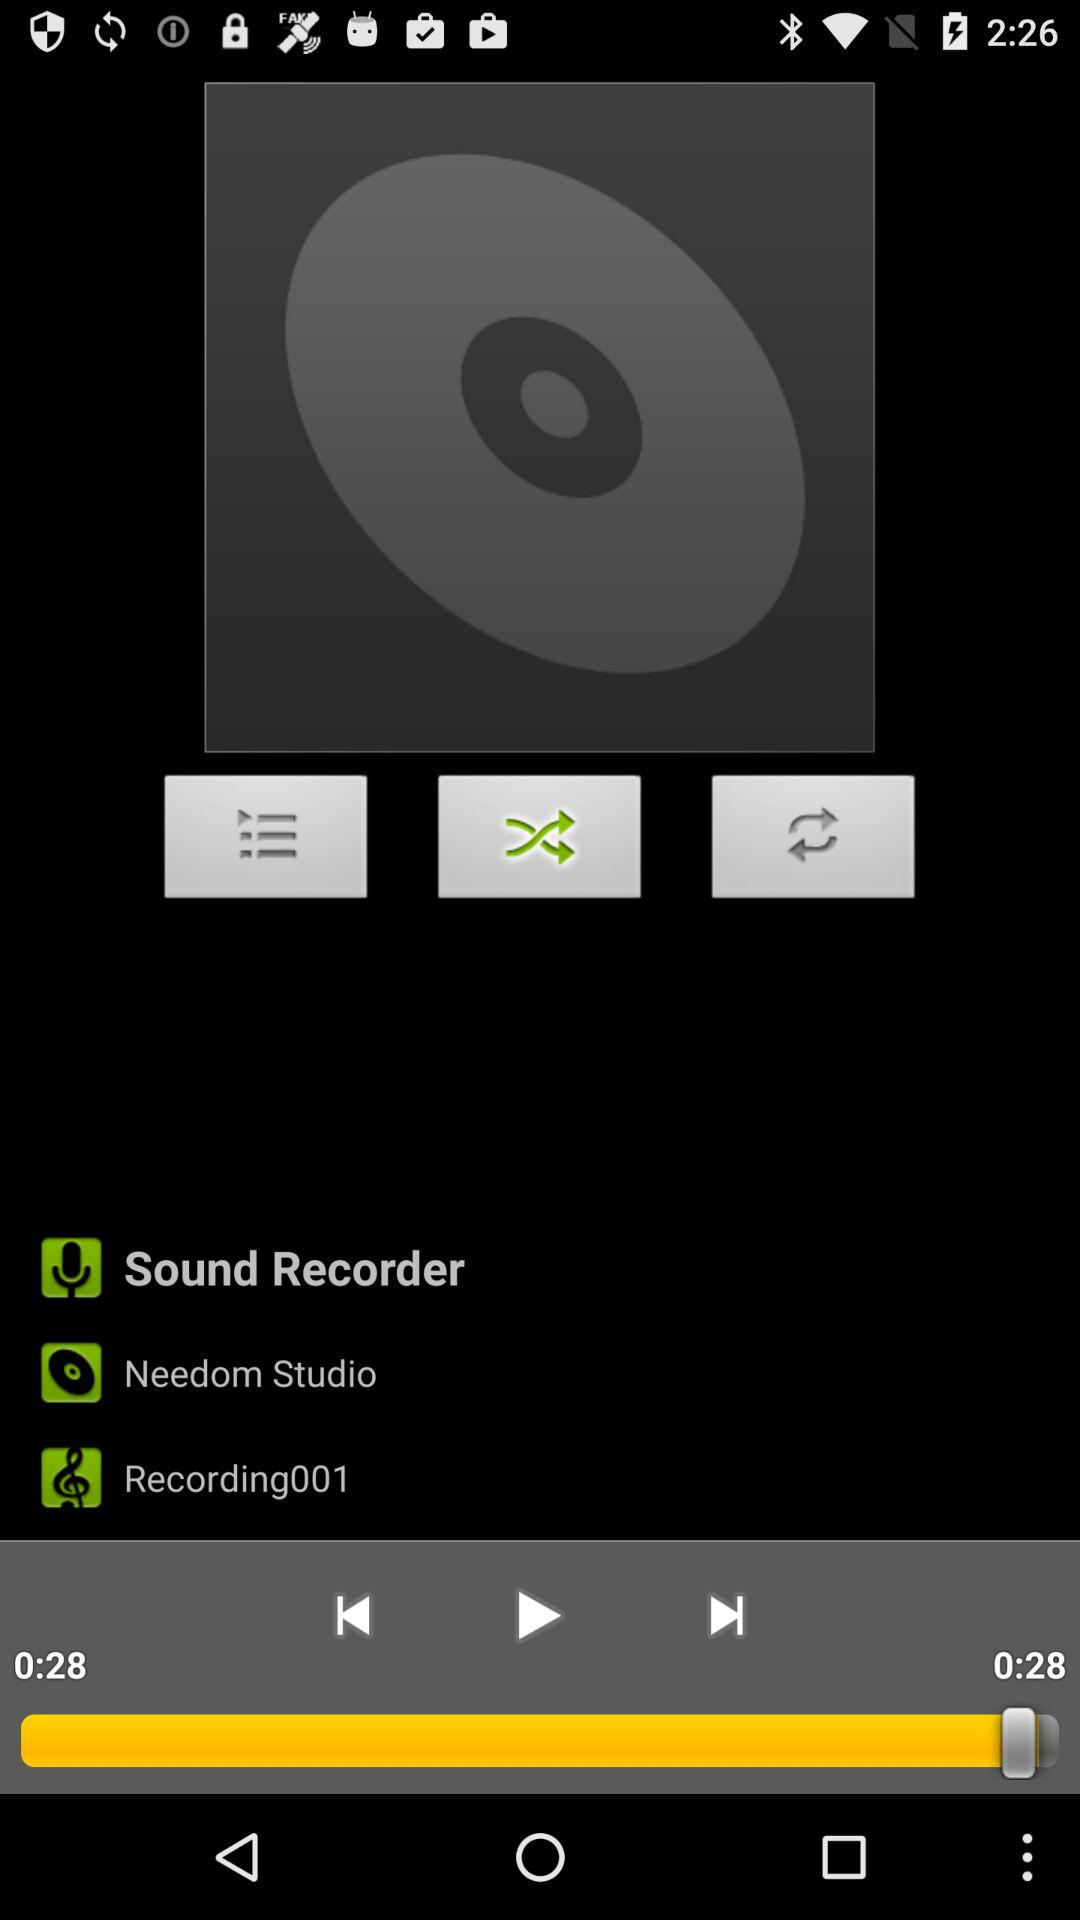How many seconds long is the recording?
Answer the question using a single word or phrase. 0:28 